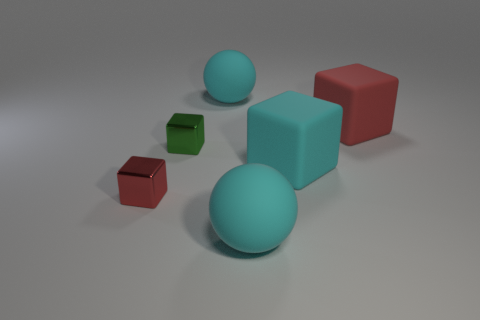Subtract 1 blocks. How many blocks are left? 3 Add 4 blue metallic cylinders. How many objects exist? 10 Subtract all balls. How many objects are left? 4 Add 5 big matte things. How many big matte things are left? 9 Add 2 tiny red matte blocks. How many tiny red matte blocks exist? 2 Subtract 0 blue blocks. How many objects are left? 6 Subtract all tiny blue rubber objects. Subtract all big red rubber blocks. How many objects are left? 5 